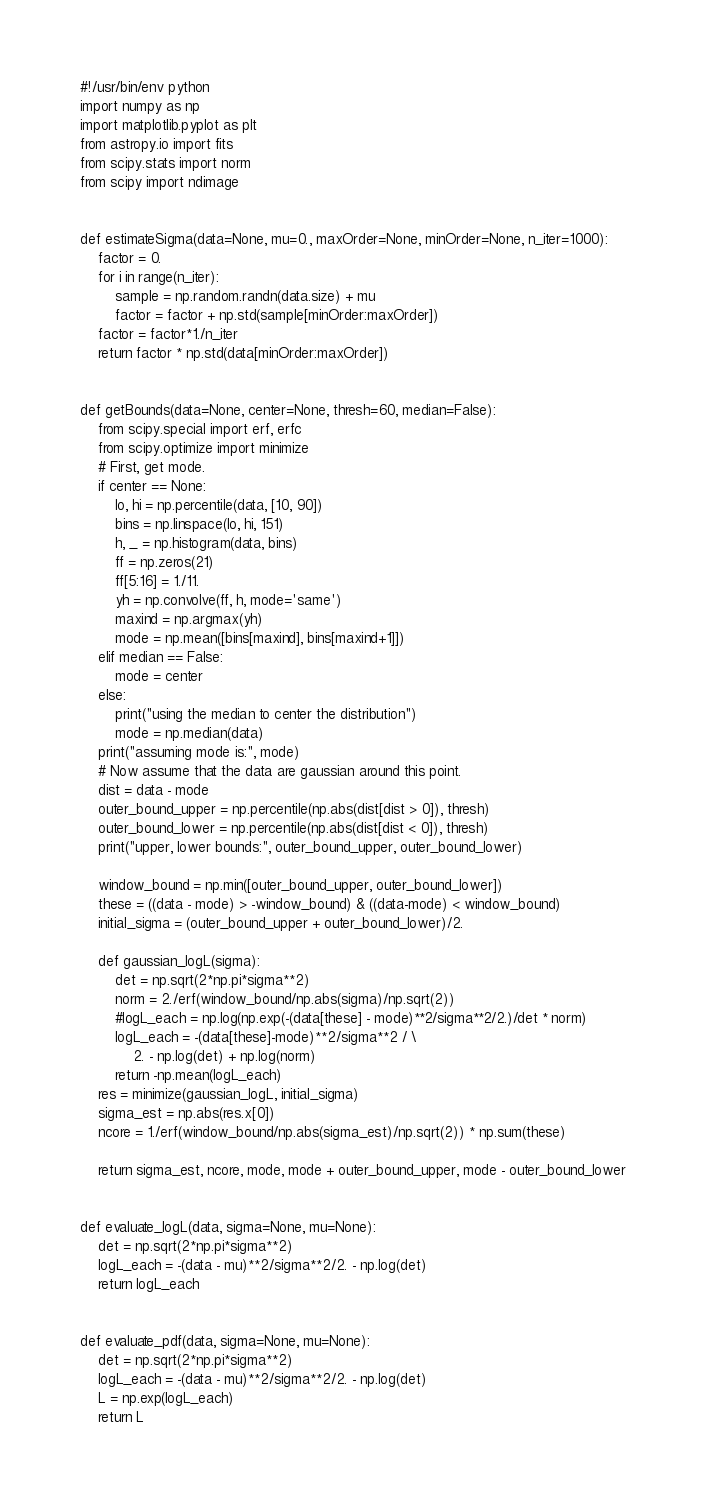<code> <loc_0><loc_0><loc_500><loc_500><_Python_>#!/usr/bin/env python
import numpy as np
import matplotlib.pyplot as plt
from astropy.io import fits
from scipy.stats import norm
from scipy import ndimage


def estimateSigma(data=None, mu=0., maxOrder=None, minOrder=None, n_iter=1000):
    factor = 0.
    for i in range(n_iter):
        sample = np.random.randn(data.size) + mu
        factor = factor + np.std(sample[minOrder:maxOrder])
    factor = factor*1./n_iter
    return factor * np.std(data[minOrder:maxOrder])


def getBounds(data=None, center=None, thresh=60, median=False):
    from scipy.special import erf, erfc
    from scipy.optimize import minimize
    # First, get mode.
    if center == None:
        lo, hi = np.percentile(data, [10, 90])
        bins = np.linspace(lo, hi, 151)
        h, _ = np.histogram(data, bins)
        ff = np.zeros(21)
        ff[5:16] = 1./11.
        yh = np.convolve(ff, h, mode='same')
        maxind = np.argmax(yh)
        mode = np.mean([bins[maxind], bins[maxind+1]])
    elif median == False:
        mode = center
    else:
        print("using the median to center the distribution")
        mode = np.median(data)
    print("assuming mode is:", mode)
    # Now assume that the data are gaussian around this point.
    dist = data - mode
    outer_bound_upper = np.percentile(np.abs(dist[dist > 0]), thresh)
    outer_bound_lower = np.percentile(np.abs(dist[dist < 0]), thresh)
    print("upper, lower bounds:", outer_bound_upper, outer_bound_lower)

    window_bound = np.min([outer_bound_upper, outer_bound_lower])
    these = ((data - mode) > -window_bound) & ((data-mode) < window_bound)
    initial_sigma = (outer_bound_upper + outer_bound_lower)/2.

    def gaussian_logL(sigma):
        det = np.sqrt(2*np.pi*sigma**2)
        norm = 2./erf(window_bound/np.abs(sigma)/np.sqrt(2))
        #logL_each = np.log(np.exp(-(data[these] - mode)**2/sigma**2/2.)/det * norm)
        logL_each = -(data[these]-mode)**2/sigma**2 / \
            2. - np.log(det) + np.log(norm)
        return -np.mean(logL_each)
    res = minimize(gaussian_logL, initial_sigma)
    sigma_est = np.abs(res.x[0])
    ncore = 1./erf(window_bound/np.abs(sigma_est)/np.sqrt(2)) * np.sum(these)

    return sigma_est, ncore, mode, mode + outer_bound_upper, mode - outer_bound_lower


def evaluate_logL(data, sigma=None, mu=None):
    det = np.sqrt(2*np.pi*sigma**2)
    logL_each = -(data - mu)**2/sigma**2/2. - np.log(det)
    return logL_each


def evaluate_pdf(data, sigma=None, mu=None):
    det = np.sqrt(2*np.pi*sigma**2)
    logL_each = -(data - mu)**2/sigma**2/2. - np.log(det)
    L = np.exp(logL_each)
    return L

</code> 